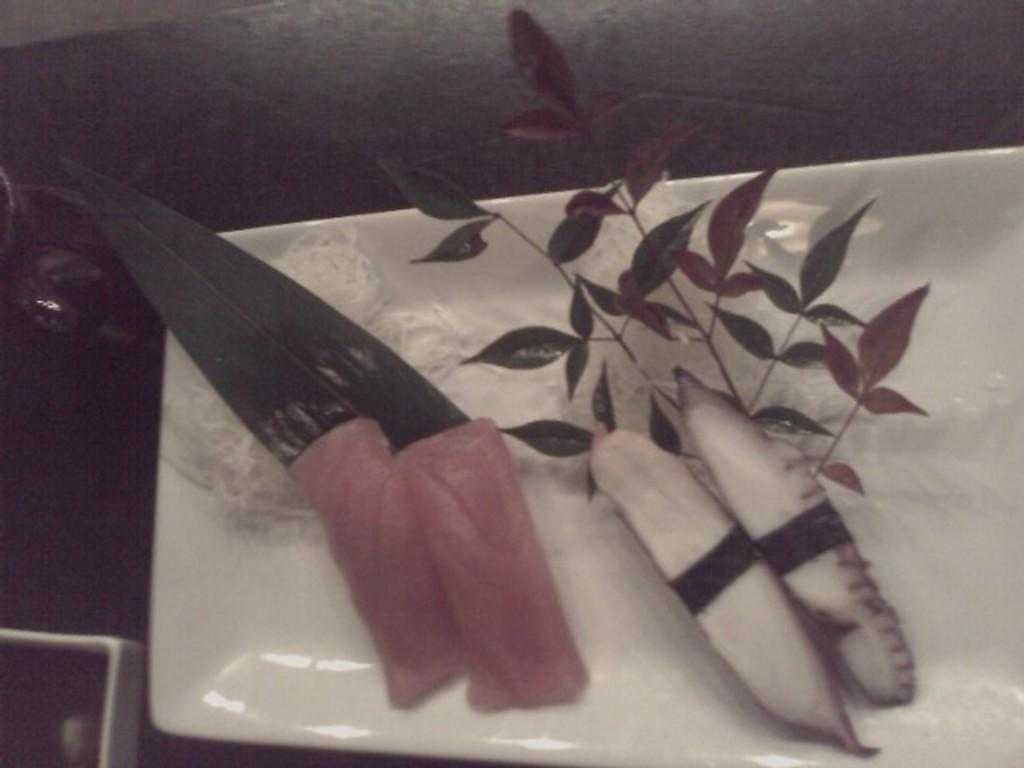What is on the plate that is visible in the image? There is meat on a plate in the image. What else is on the plate besides the meat? There are leaves on the plate in the image. What color is the plate? The plate is white. Where is the plate located in the image? The plate is on a table. What type of polish is being applied to the meat in the image? There is no indication in the image that any polish is being applied to the meat. 